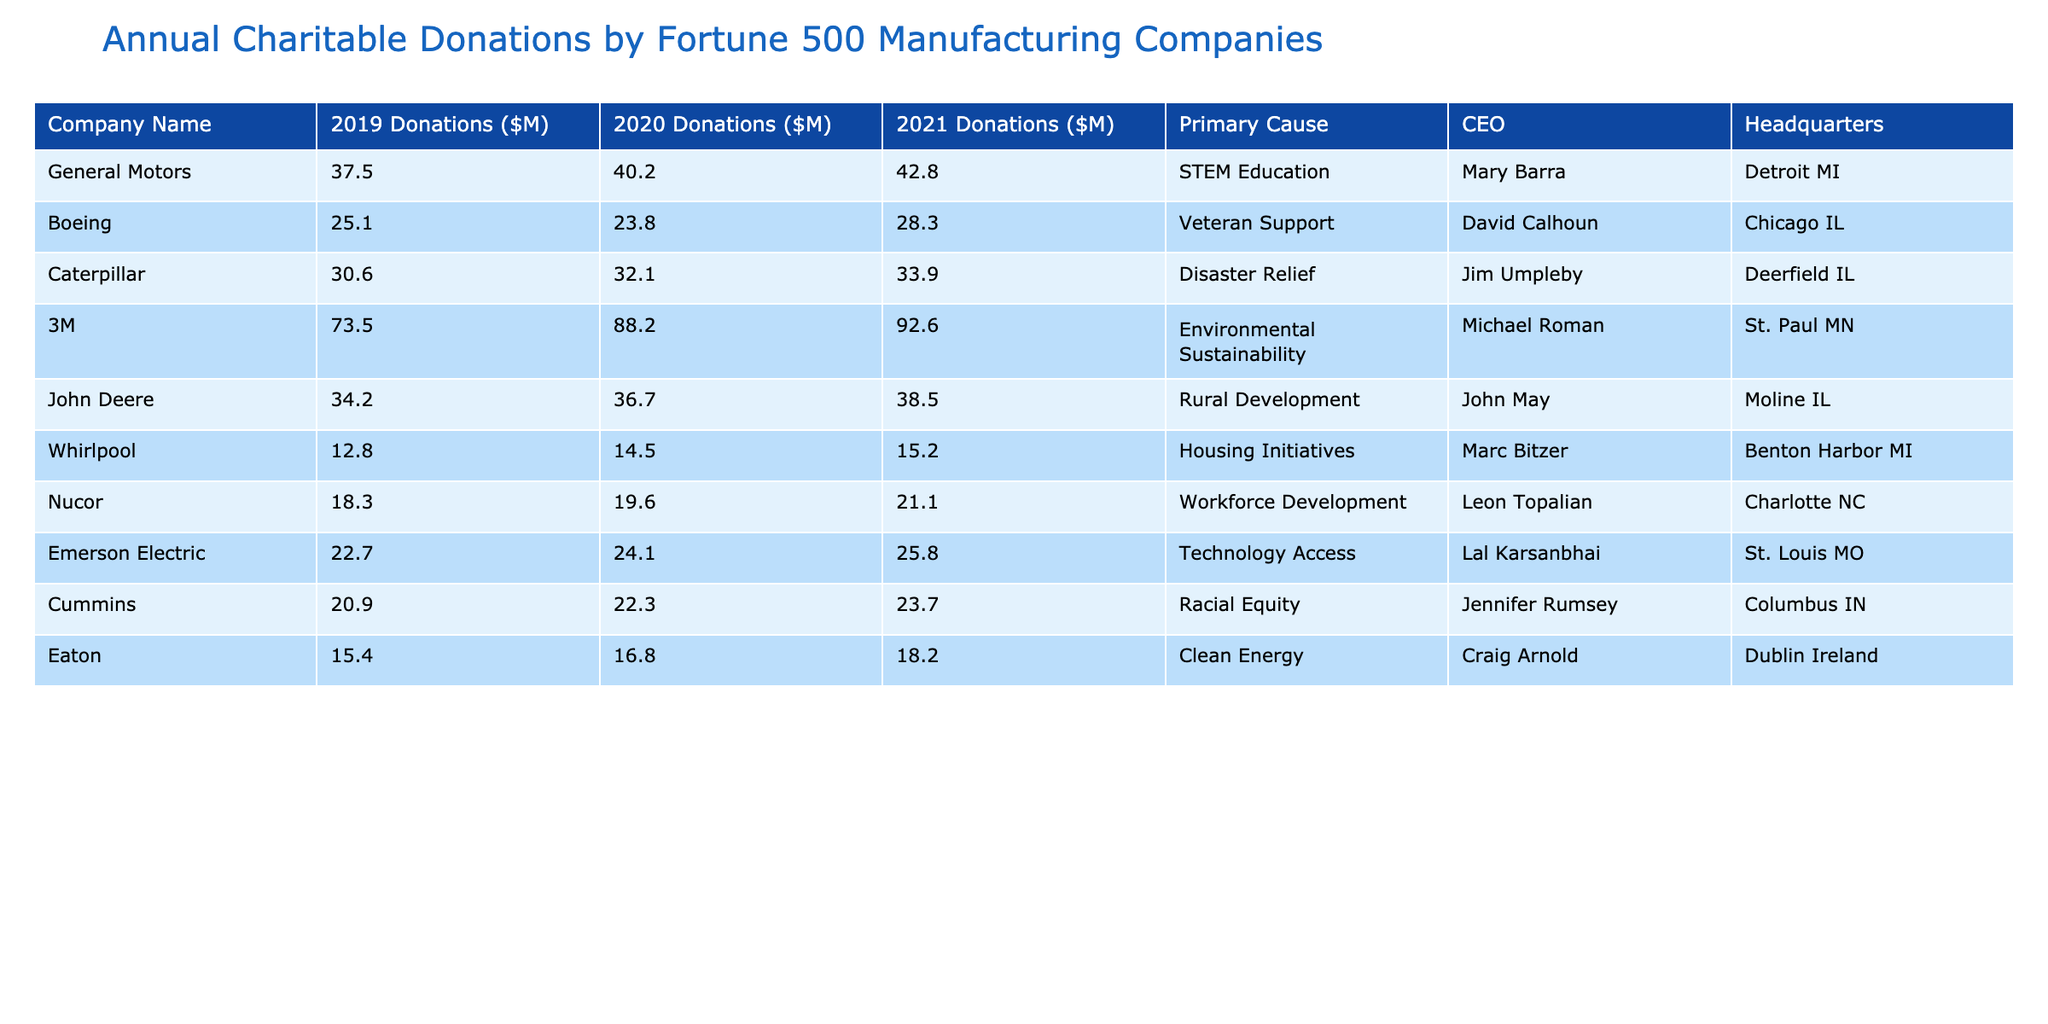What was the highest donation made by a company in 2021? In 2021, the donation values for each company are listed. By comparing the values, 3M has the highest donation at $92.6 million.
Answer: 92.6 million Which company donated the least in 2020? Looking at the 2020 donations, Whirlpool donated $14.5 million, which is less than all other companies listed.
Answer: Whirlpool What is the total amount donated by Caterpillar from 2019 to 2021? The donations from Caterpillar over the three years are $30.6 million (2019), $32.1 million (2020), and $33.9 million (2021). Summing these gives: 30.6 + 32.1 + 33.9 = 96.6 million.
Answer: 96.6 million Did any company increase its donations every year from 2019 to 2021? By examining the annual donations, we see that 3M's donations increased each year: from $73.5 million in 2019 to $88.2 million in 2020, and $92.6 million in 2021.
Answer: Yes What is the average donation from Nucor over the three years? To find the average, add the three donations: 18.3 + 19.6 + 21.1 = 59.0 million, then divide by 3, which equals 19.67 million.
Answer: 19.67 million Which company's donations had the largest percentage increase from 2019 to 2021? First, calculate the percentage change for each company from 2019 to 2021. For 3M, the change is ((92.6 - 73.5) / 73.5) * 100% ≈ 26.0%. Then repeat for others and find the largest. After comparing, 3M shows the largest increase.
Answer: 3M What primary cause did General Motors support? The table lists the primary cause for each company; General Motors supports STEM Education.
Answer: STEM Education How much more did 3M donate in 2021 compared to Boeing? For 2021, 3M donated $92.6 million and Boeing donated $28.3 million. The difference is 92.6 - 28.3 = 64.3 million.
Answer: 64.3 million 